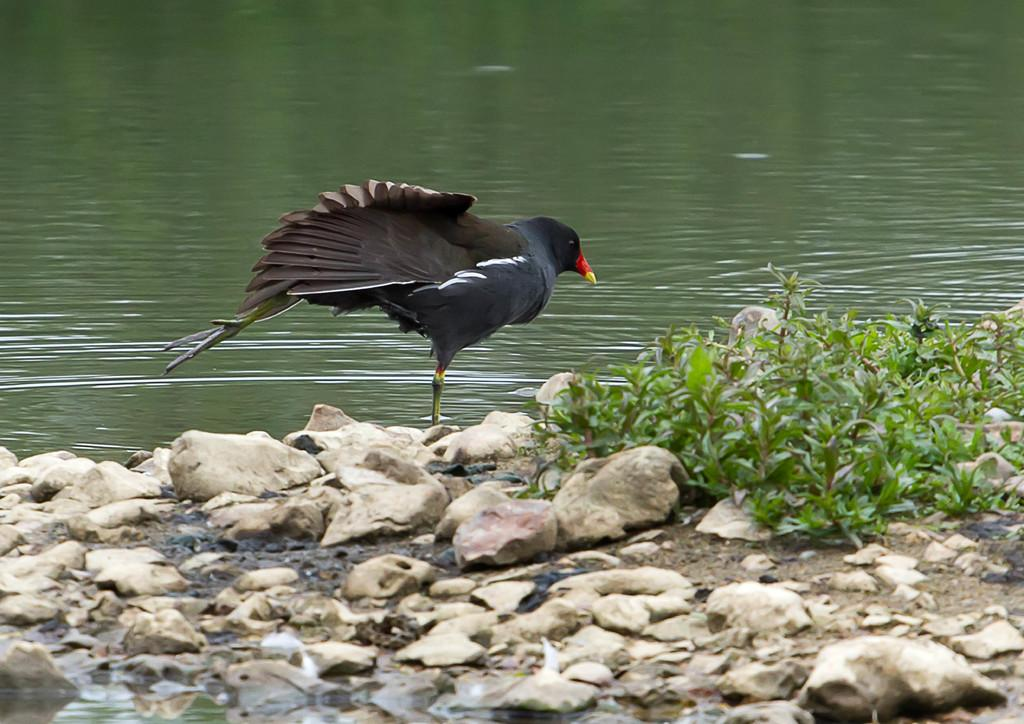What type of bird can be seen in the image? There is a black color bird in the image. Where is the bird located? The bird is on the land. What else can be found on the land in the image? There are stones and small plants on the land. What can be seen in the background of the image? There is water visible in the background of the image. How many knives are being used by the bird in the image? There are no knives present in the image, and the bird is not using any tools. 